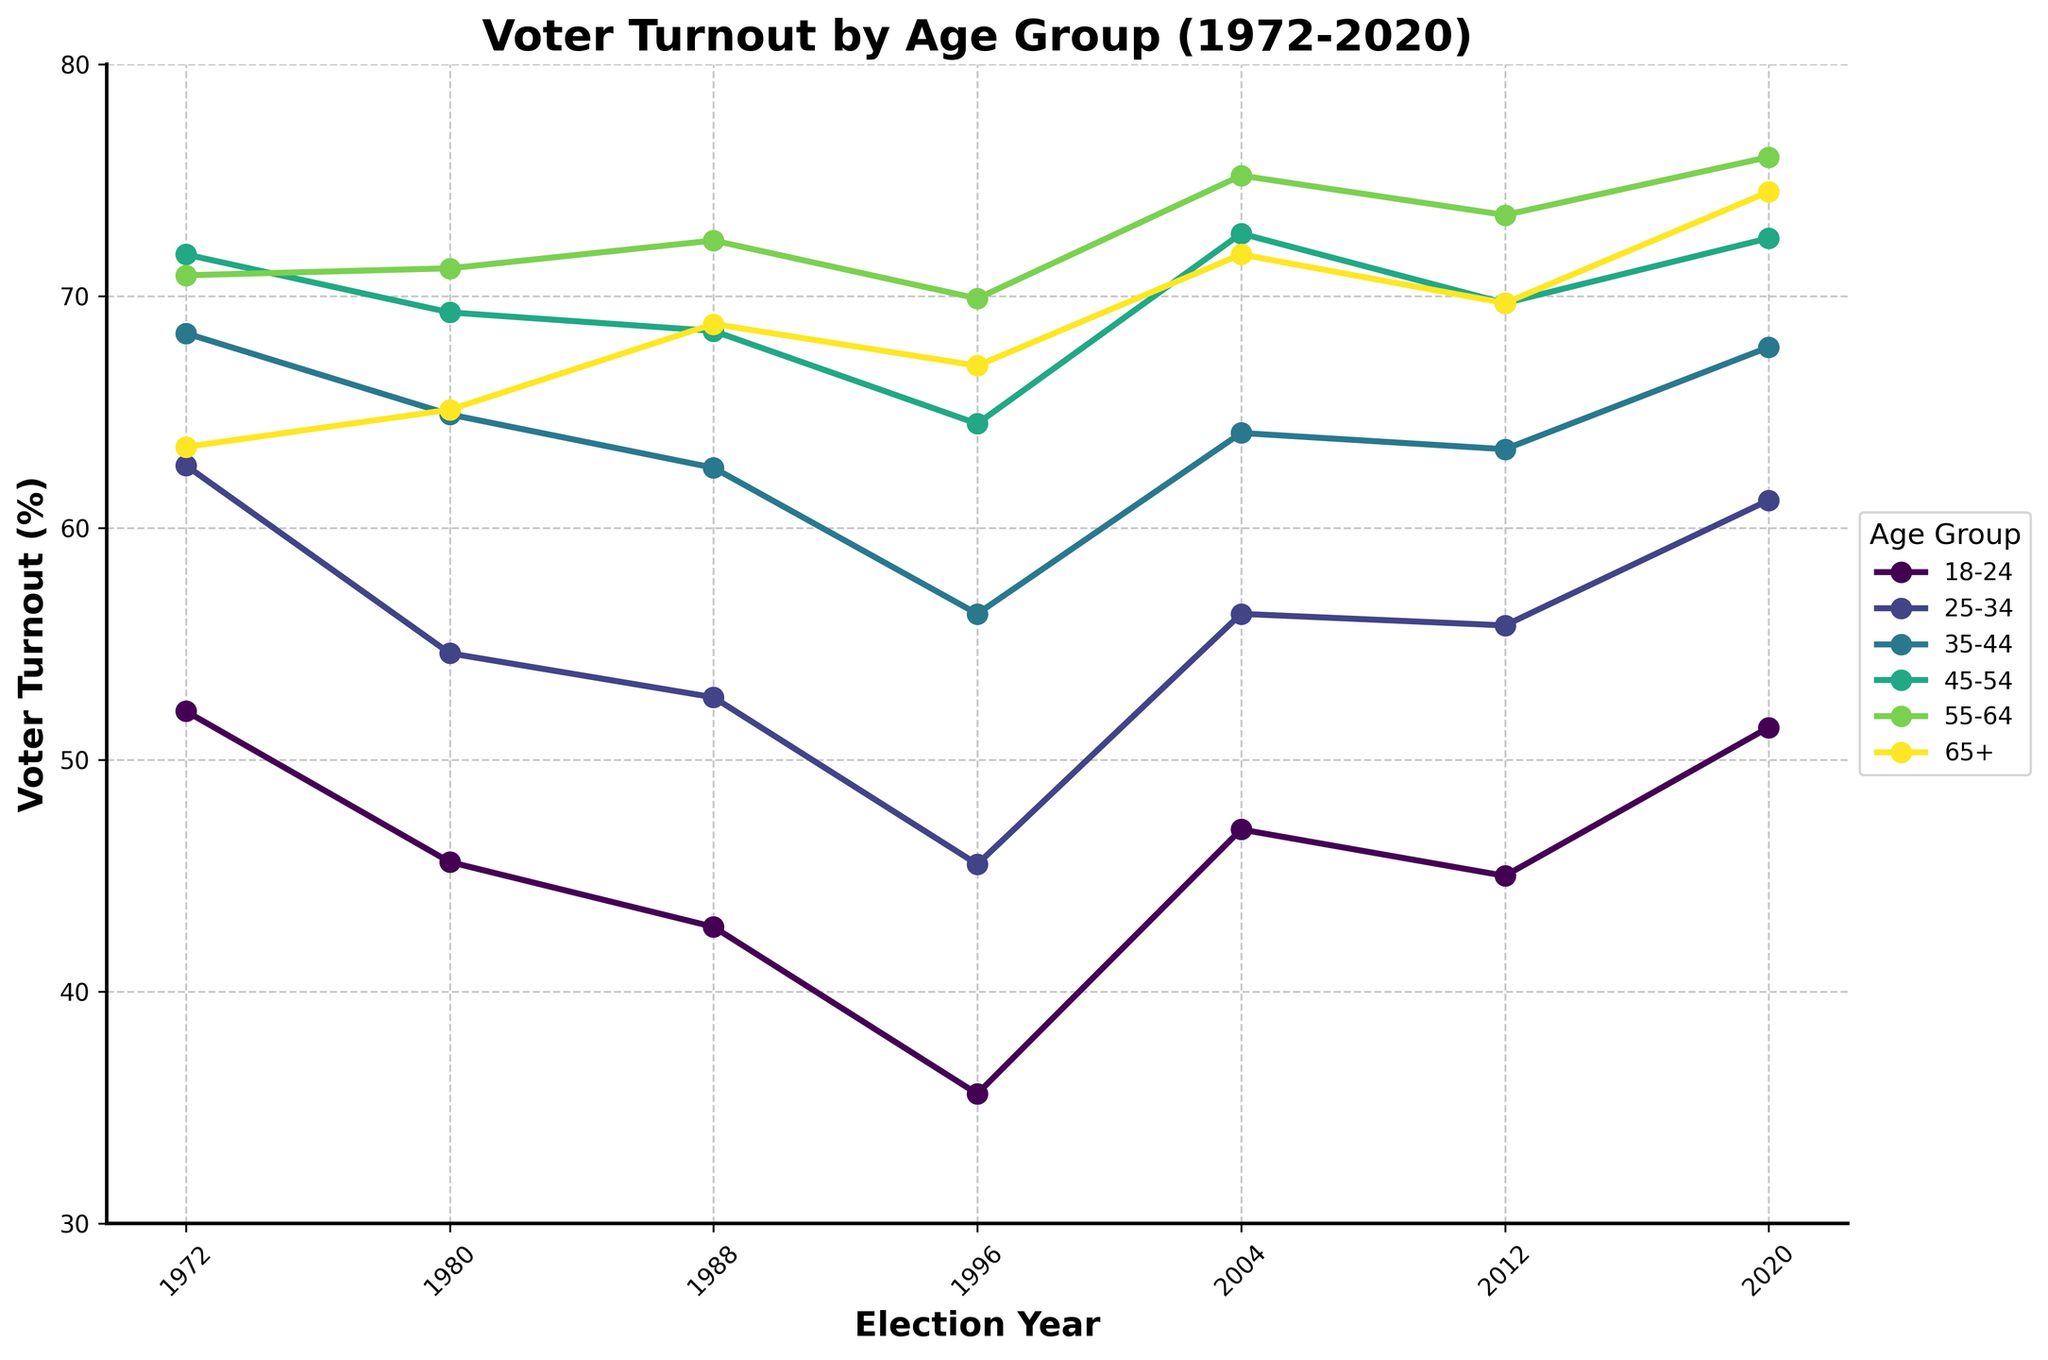What age group had the highest voter turnout in the 1980 election? First, look at the 1980 data values on the x-axis and identify which age group has the highest y-axis value (voter turnout percentage). The 45-54 age group has the highest turnout at 69.3%.
Answer: 45-54 Which age group showed the most significant increase in voter turnout between 1996 and 2020? Calculate the difference in voter turnout for each age group between 1996 and 2020 by subtracting the 1996 value from the 2020 value. The most significant increase is for the 18-24 age group, going from 35.6% to 51.4%, an increase of 15.8%.
Answer: 18-24 By how much did the voter turnout of the 25-34 age group increase from 1988 to 2004? Subtract the 1988 turnout value for the 25-34 age group from the 2004 value. The increase is 56.3% - 52.7% = 3.6%.
Answer: 3.6% In which election year did the 55-64 age group have the highest voter turnout? Identify the highest y-axis value for the 55-64 age group across the years and determine its corresponding election year. The highest turnout, 76.0%, was in the 2020 election.
Answer: 2020 Which two age groups had the closest voter turnout percentages in the 2012 election? Compare the voter turnout percentages for all age groups in 2012 and identify the two closest values. The 45-54 and 65+ age groups had turnout percentages of 69.7%, making them the closest.
Answer: 45-54 and 65+ What is the average voter turnout for the 35-44 age group over the 50-year period shown? Sum the voter turnout values for the 35-44 age group across all years and divide by the number of years. The sum is 68.4 + 64.9 + 62.6 + 56.3 + 64.1 + 63.4 + 67.8 = 447.5. The average is 447.5 / 7 = 63.93%.
Answer: 63.93% Which age group had the lowest voter turnout in the 1996 election, and what was the percentage? Identify the lowest y-axis value for the 1996 election year and its corresponding age group. The 18-24 age group had the lowest turnout at 35.6%.
Answer: 18-24, 35.6% What was the voter turnout difference between the 18-24 and 65+ age groups in the 2004 election? Subtract the 18-24 turnout value from the 65+ turnout value for the 2004 election year. The difference is 71.8% - 47.0% = 24.8%.
Answer: 24.8% Did the 45-54 age group have a higher voter turnout than the 25-34 age group in 1988? Compare the voter turnout values for the two age groups in 1988. The 45-54 age group had a turnout of 68.5%, while the 25-34 had 52.7%. Yes, 68.5% is higher than 52.7%.
Answer: Yes In which year did the 35-44 age group see its lowest voter turnout, and what was the percentage? Identify the lowest y-axis value for the 35-44 age group across the years and determine the corresponding election year. The lowest value of 56.3% occurred in the 1996 election.
Answer: 1996, 56.3% 